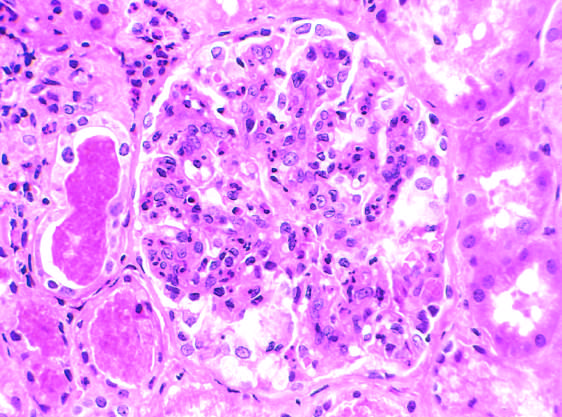s microscopic view of breast carcinoma caused by intracapillary leukocytes and proliferation of intrinsic glomerular cells?
Answer the question using a single word or phrase. No 